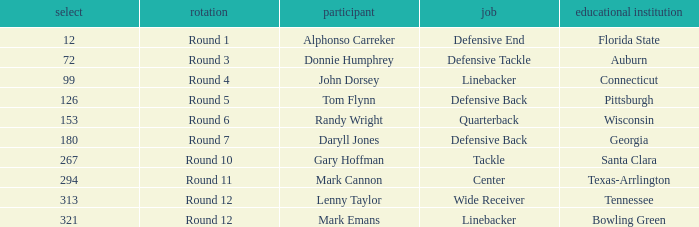What Player is a Wide Receiver? Lenny Taylor. 